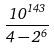<formula> <loc_0><loc_0><loc_500><loc_500>\frac { 1 0 ^ { 1 4 3 } } { 4 - 2 ^ { 6 } }</formula> 